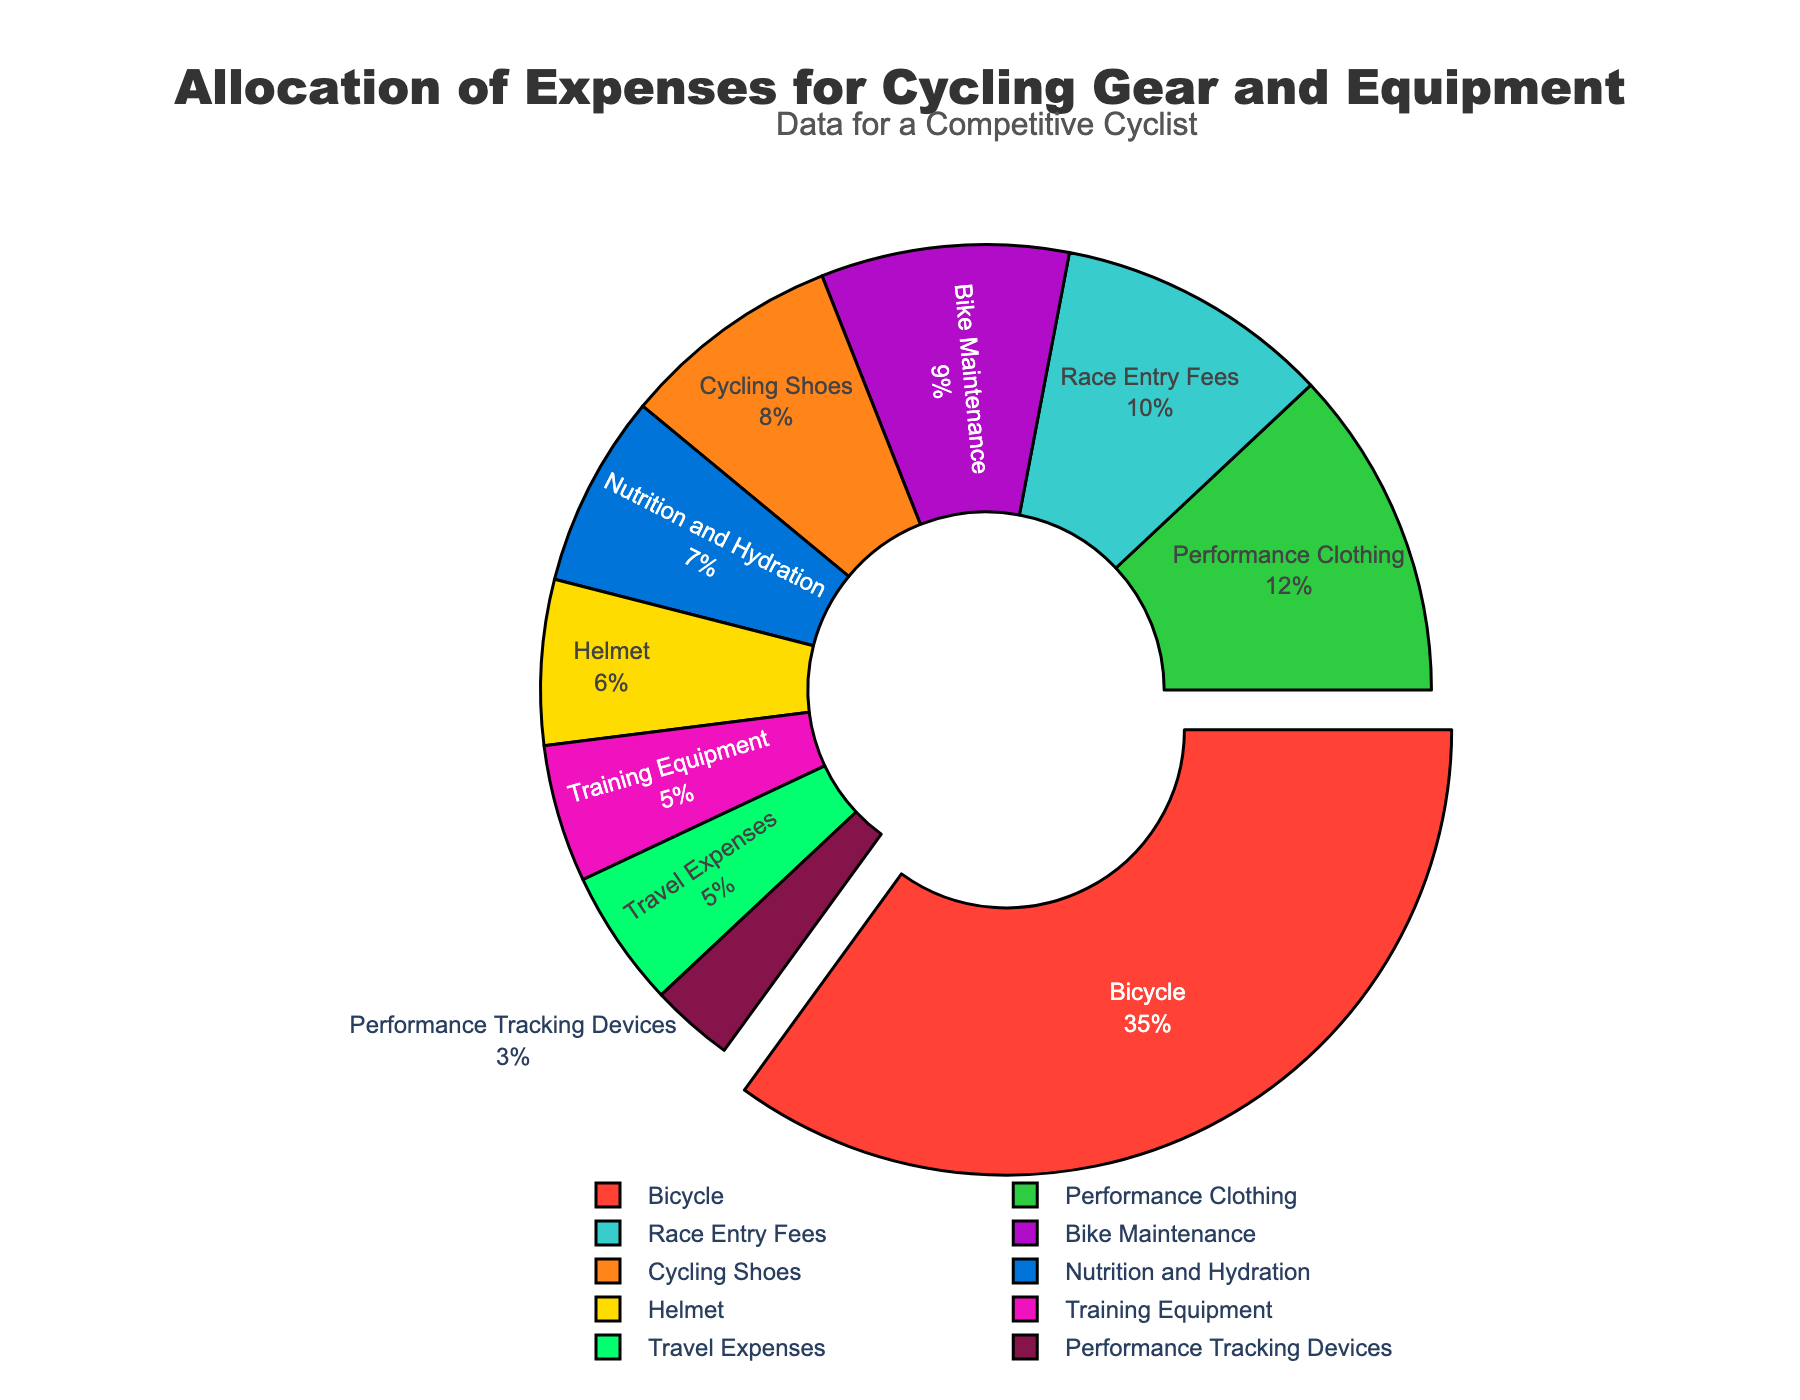Which category has the highest allocation of expenses? The pie chart indicates that the largest percentage of expenses goes to the Bicycle category, which is specifically highlighted and pulled out slightly from the rest of the chart.
Answer: Bicycle How much more is spent on Bicycle compared to Nutrition and Hydration? The percentage for Bicycle is 35%, and for Nutrition and Hydration, it is 7%. The difference in allocation is 35% - 7% = 28%.
Answer: 28% What percentage of the total expenses is spent on Performance Clothing and Race Entry Fees combined? The percentage for Performance Clothing is 12%, and for Race Entry Fees, it is 10%. Their combined total is 12% + 10% = 22%.
Answer: 22% Which expense category has the smallest allocation? The smallest section of the pie chart is the Performance Tracking Devices category, with a 3% allocation.
Answer: Performance Tracking Devices Compare the total allocation of Bike Maintenance and Training Equipment to the allocation of Race Entry Fees. Bike Maintenance is 9%, and Training Equipment is 5%. Their combined total is 9% + 5% = 14%. Race Entry Fees is 10%, which is less than the combined Bike Maintenance and Training Equipment.
Answer: Bike Maintenance and Training Equipment How many categories have an allocation greater than 10%? The categories with allocations greater than 10% are Bicycle (35%), Performance Clothing (12%), and Race Entry Fees (10%). Counting these, there are 3 such categories.
Answer: 3 What percentage is allocated to categories other than Bicycle? The total percentage is 100%, and the Bicycle category takes up 35%. Subtracting this, the allocation to other categories is 100% - 35% = 65%.
Answer: 65% Are Travel Expenses and Training Equipment allocated the same percentage? Both Travel Expenses and Training Equipment have an equal allocation of 5%.
Answer: Yes What is the percentage difference between Cycling Shoes and Helmet expenses? The percentage for Cycling Shoes is 8%, and for Helmet, it is 6%. The difference is 8% - 6% = 2%.
Answer: 2% Is the allocation for Cycling Shoes greater than the combined allocation for Nutrition and Hydration, and Performance Tracking Devices? Cycling Shoes allocation is 8%. Nutrition and Hydration is 7%, and Performance Tracking Devices is 3%. Their combined allocation is 7% + 3% = 10%, which is greater than Cycling Shoes at 8%.
Answer: No 